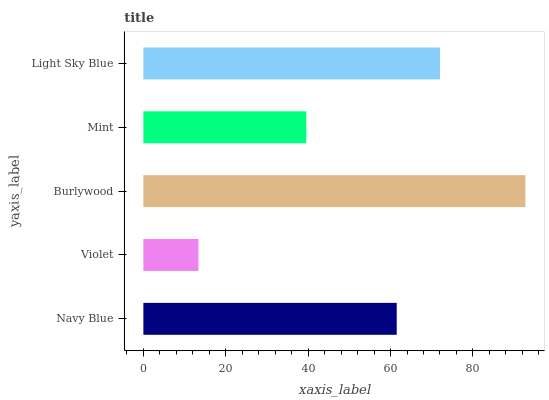Is Violet the minimum?
Answer yes or no. Yes. Is Burlywood the maximum?
Answer yes or no. Yes. Is Burlywood the minimum?
Answer yes or no. No. Is Violet the maximum?
Answer yes or no. No. Is Burlywood greater than Violet?
Answer yes or no. Yes. Is Violet less than Burlywood?
Answer yes or no. Yes. Is Violet greater than Burlywood?
Answer yes or no. No. Is Burlywood less than Violet?
Answer yes or no. No. Is Navy Blue the high median?
Answer yes or no. Yes. Is Navy Blue the low median?
Answer yes or no. Yes. Is Violet the high median?
Answer yes or no. No. Is Burlywood the low median?
Answer yes or no. No. 